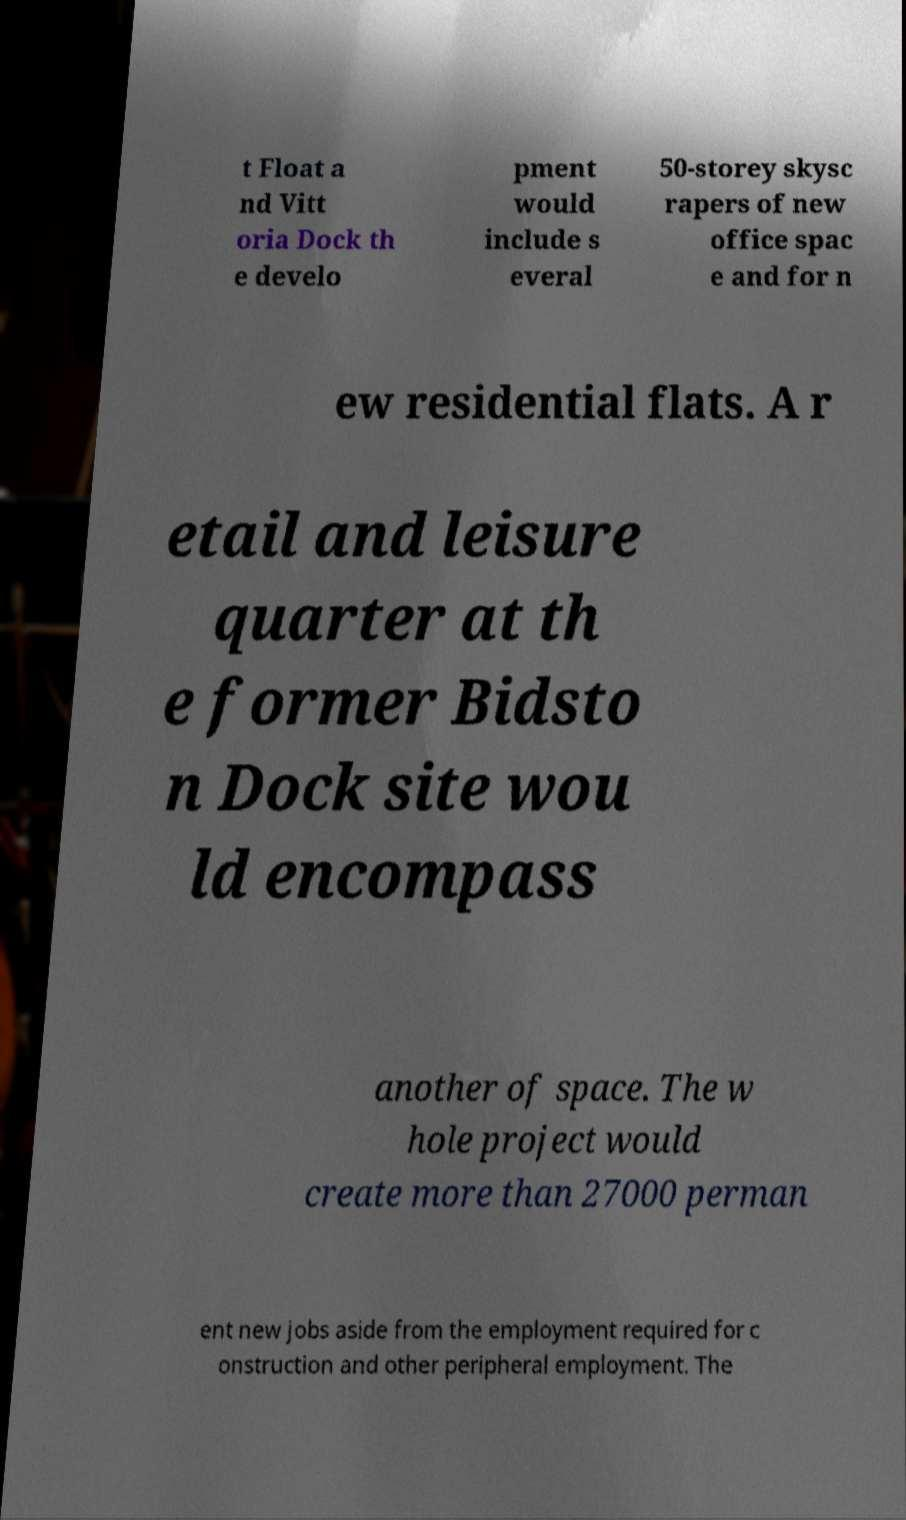What messages or text are displayed in this image? I need them in a readable, typed format. t Float a nd Vitt oria Dock th e develo pment would include s everal 50-storey skysc rapers of new office spac e and for n ew residential flats. A r etail and leisure quarter at th e former Bidsto n Dock site wou ld encompass another of space. The w hole project would create more than 27000 perman ent new jobs aside from the employment required for c onstruction and other peripheral employment. The 